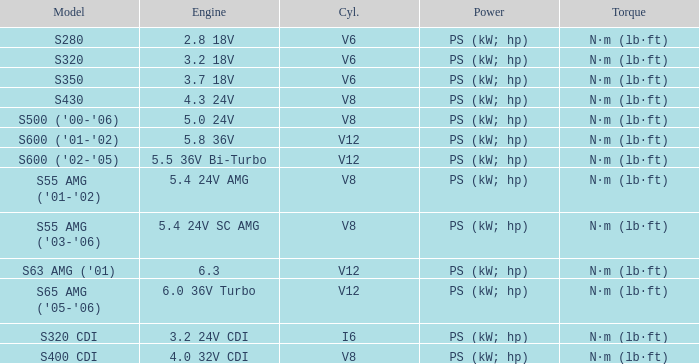Which torque is featured in a model of s63 amg ('01)? N·m (lb·ft). Would you mind parsing the complete table? {'header': ['Model', 'Engine', 'Cyl.', 'Power', 'Torque'], 'rows': [['S280', '2.8 18V', 'V6', 'PS (kW; hp)', 'N·m (lb·ft)'], ['S320', '3.2 18V', 'V6', 'PS (kW; hp)', 'N·m (lb·ft)'], ['S350', '3.7 18V', 'V6', 'PS (kW; hp)', 'N·m (lb·ft)'], ['S430', '4.3 24V', 'V8', 'PS (kW; hp)', 'N·m (lb·ft)'], ["S500 ('00-'06)", '5.0 24V', 'V8', 'PS (kW; hp)', 'N·m (lb·ft)'], ["S600 ('01-'02)", '5.8 36V', 'V12', 'PS (kW; hp)', 'N·m (lb·ft)'], ["S600 ('02-'05)", '5.5 36V Bi-Turbo', 'V12', 'PS (kW; hp)', 'N·m (lb·ft)'], ["S55 AMG ('01-'02)", '5.4 24V AMG', 'V8', 'PS (kW; hp)', 'N·m (lb·ft)'], ["S55 AMG ('03-'06)", '5.4 24V SC AMG', 'V8', 'PS (kW; hp)', 'N·m (lb·ft)'], ["S63 AMG ('01)", '6.3', 'V12', 'PS (kW; hp)', 'N·m (lb·ft)'], ["S65 AMG ('05-'06)", '6.0 36V Turbo', 'V12', 'PS (kW; hp)', 'N·m (lb·ft)'], ['S320 CDI', '3.2 24V CDI', 'I6', 'PS (kW; hp)', 'N·m (lb·ft)'], ['S400 CDI', '4.0 32V CDI', 'V8', 'PS (kW; hp)', 'N·m (lb·ft)']]} 